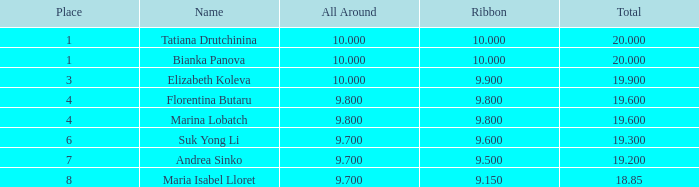Which area had a ribbon lower than 7.0. 